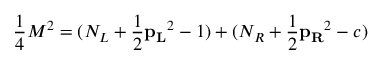<formula> <loc_0><loc_0><loc_500><loc_500>{ \frac { 1 } { 4 } } M ^ { 2 } = ( N _ { L } + { \frac { 1 } { 2 } } { p _ { L } } ^ { 2 } - 1 ) + ( N _ { R } + { \frac { 1 } { 2 } } { p _ { R } } ^ { 2 } - c )</formula> 